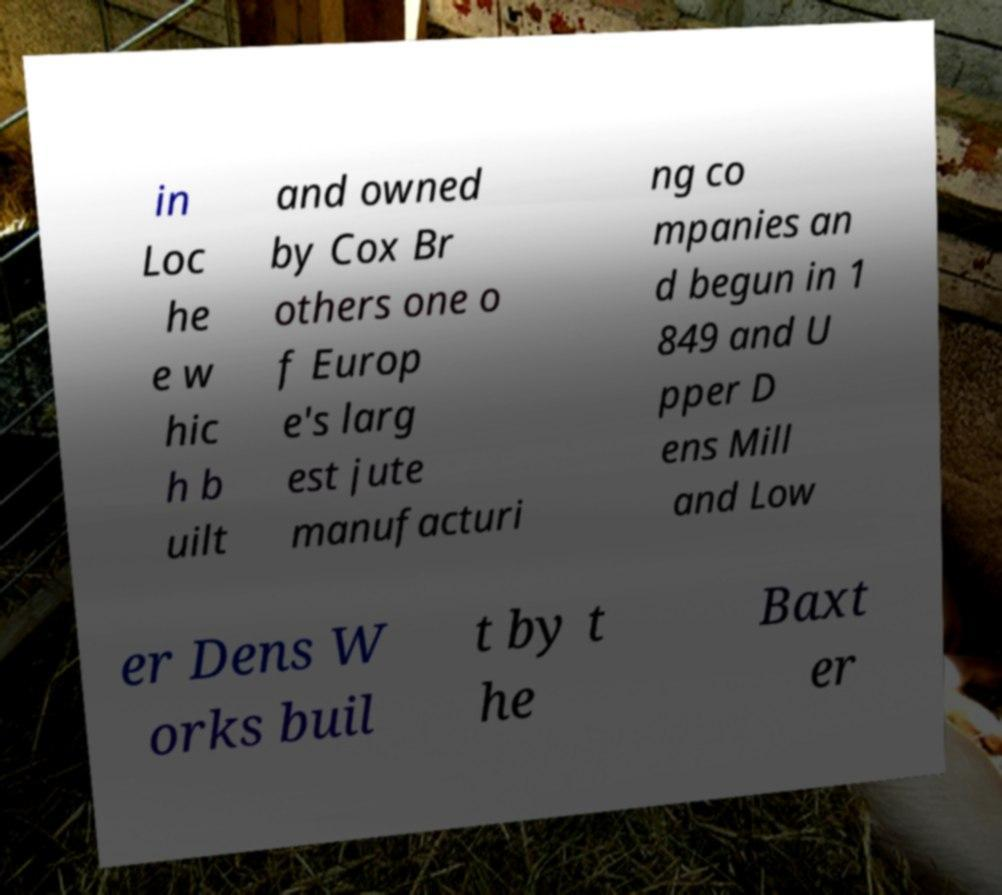For documentation purposes, I need the text within this image transcribed. Could you provide that? in Loc he e w hic h b uilt and owned by Cox Br others one o f Europ e's larg est jute manufacturi ng co mpanies an d begun in 1 849 and U pper D ens Mill and Low er Dens W orks buil t by t he Baxt er 